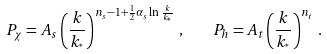Convert formula to latex. <formula><loc_0><loc_0><loc_500><loc_500>P _ { \chi } = A _ { s } \left ( { \frac { k } { k _ { ^ { * } } } } \right ) ^ { n _ { s } - 1 + { \frac { 1 } { 2 } } \alpha _ { s } \ln { \frac { k } { k _ { ^ { * } } } } } \, , \quad P _ { h } = A _ { t } \left ( { \frac { k } { k _ { ^ { * } } } } \right ) ^ { n _ { t } } \, .</formula> 